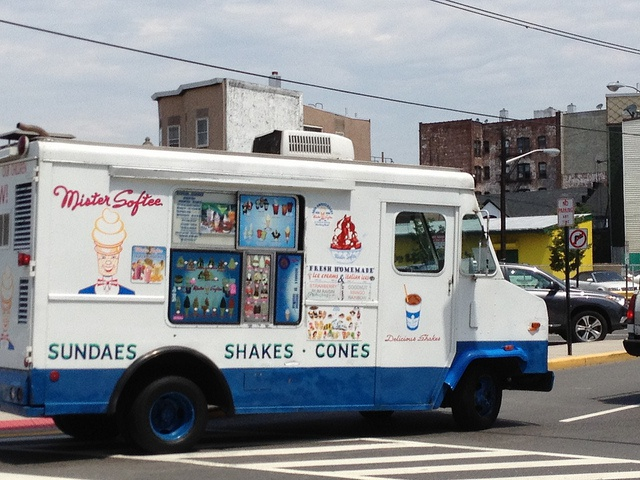Describe the objects in this image and their specific colors. I can see truck in lightgray, black, darkgray, and navy tones, car in lightgray, black, gray, and darkgray tones, car in lightgray, gray, darkgray, and darkblue tones, and car in lightgray, black, gray, darkgray, and maroon tones in this image. 